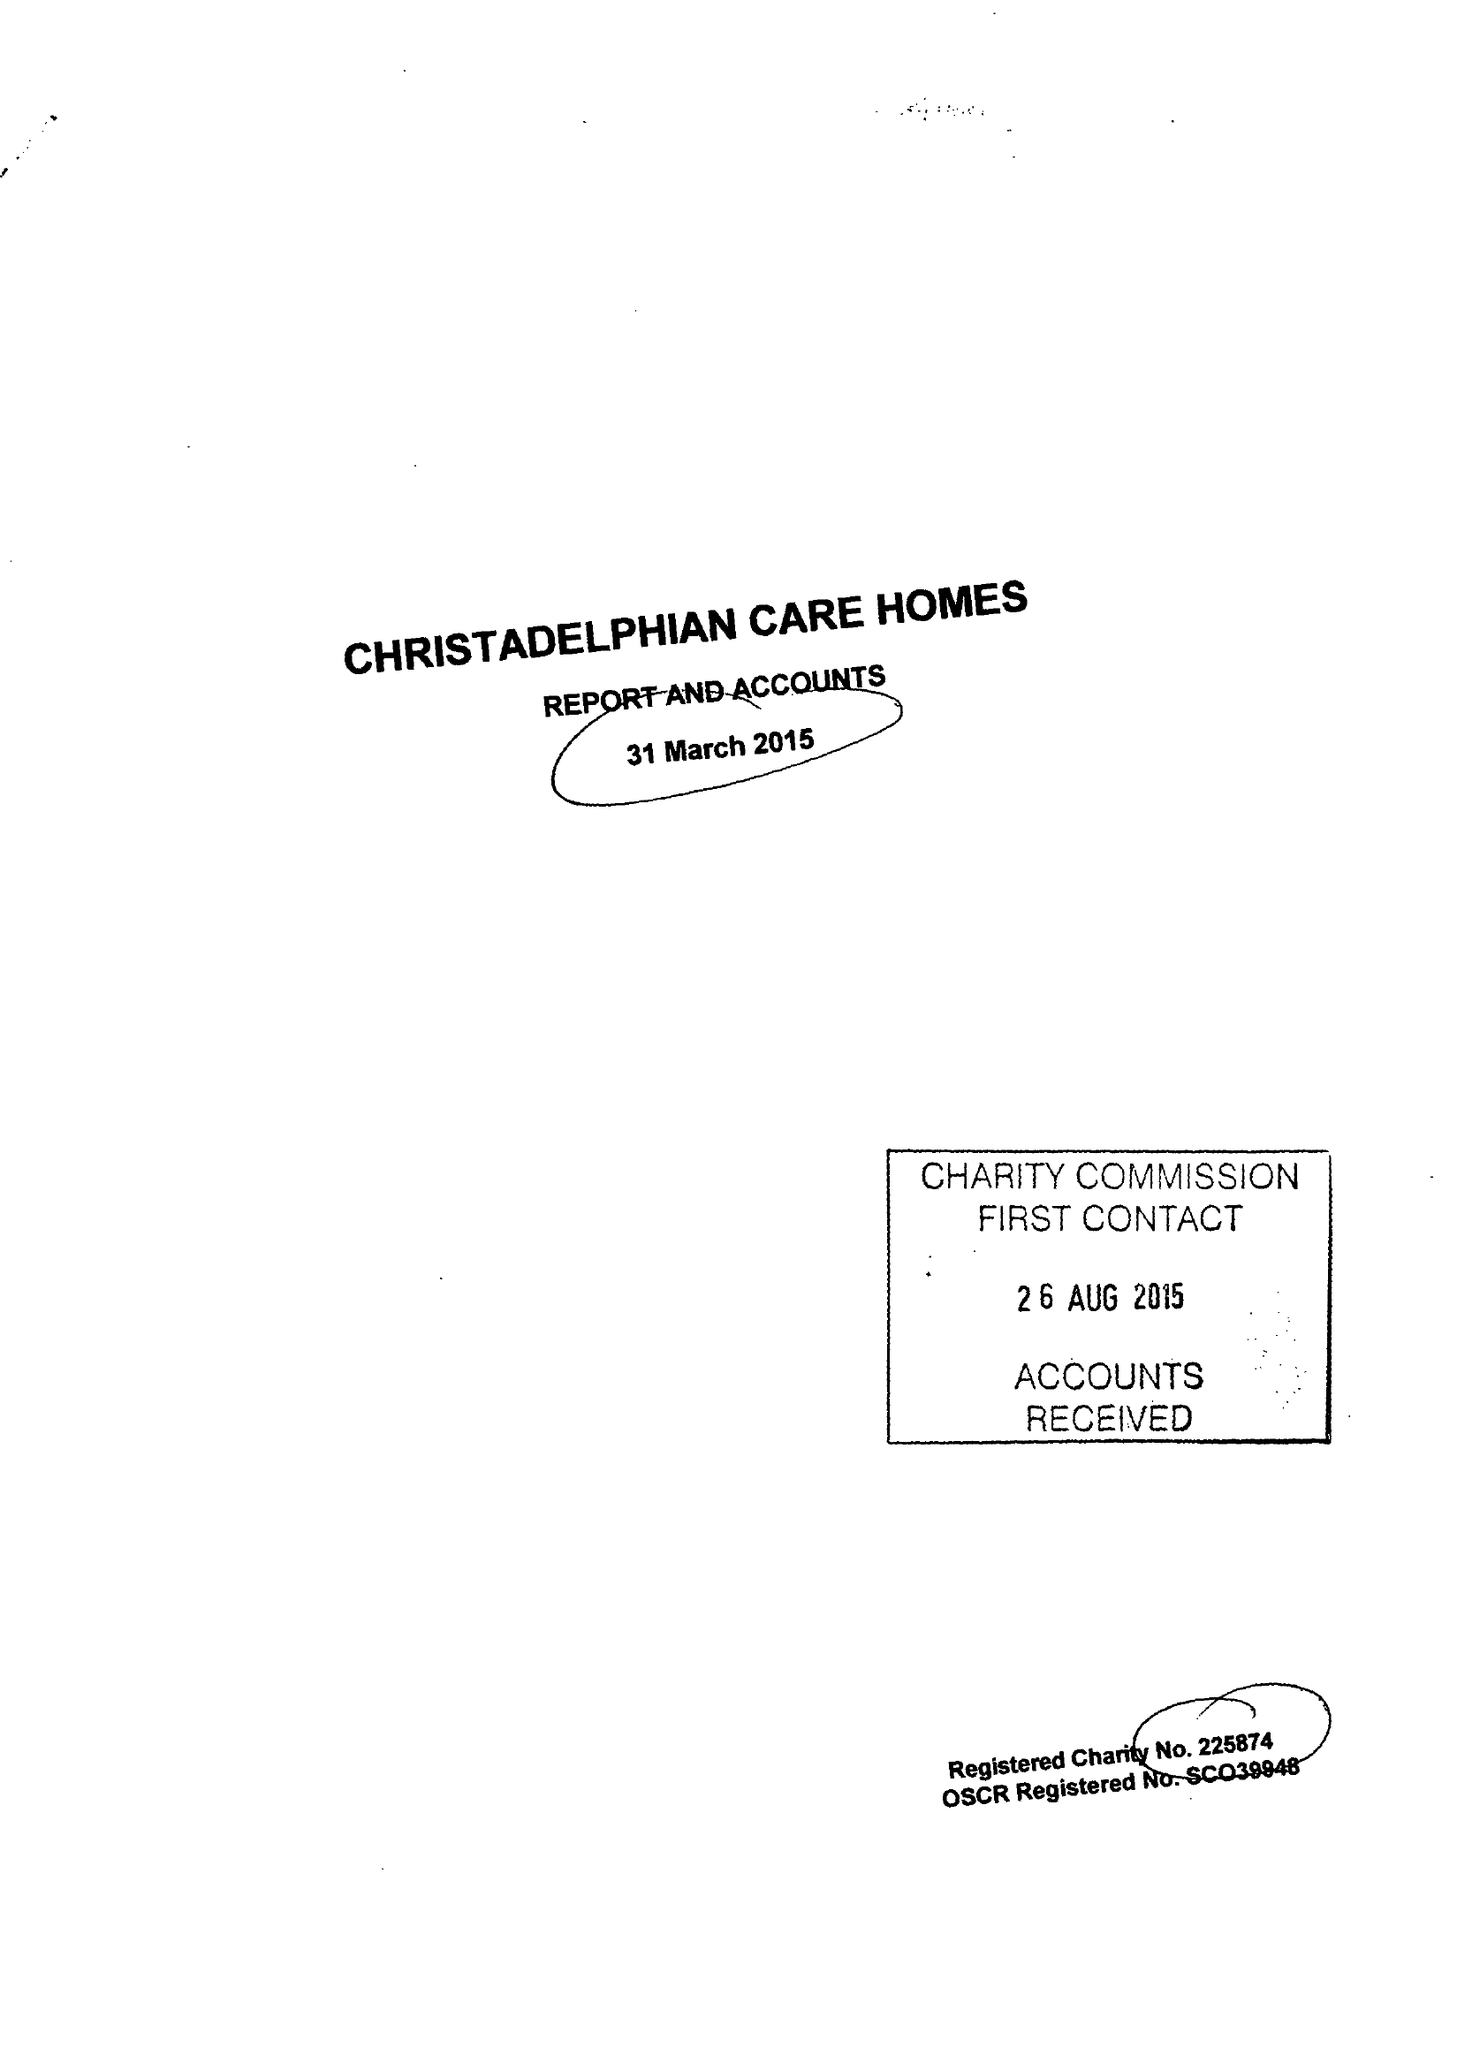What is the value for the spending_annually_in_british_pounds?
Answer the question using a single word or phrase. 8877272.00 